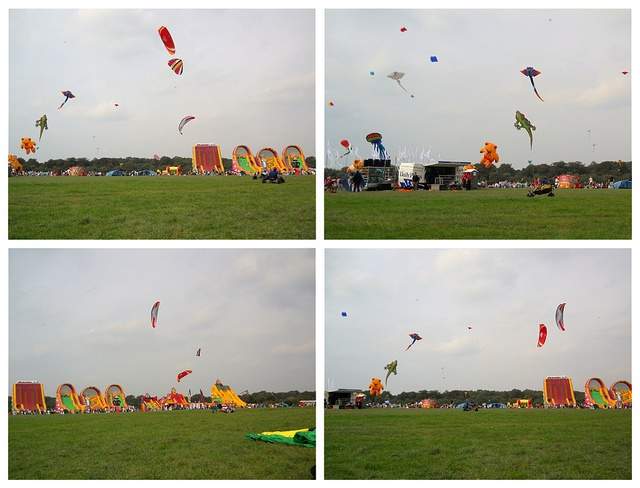Describe the objects in this image and their specific colors. I can see kite in white, lightgray, darkgray, darkgreen, and black tones, kite in white, brown, and red tones, kite in white, olive, gray, darkgray, and darkgreen tones, kite in white, lightgray, gray, purple, and navy tones, and kite in white, lightgray, brown, darkgray, and gray tones in this image. 